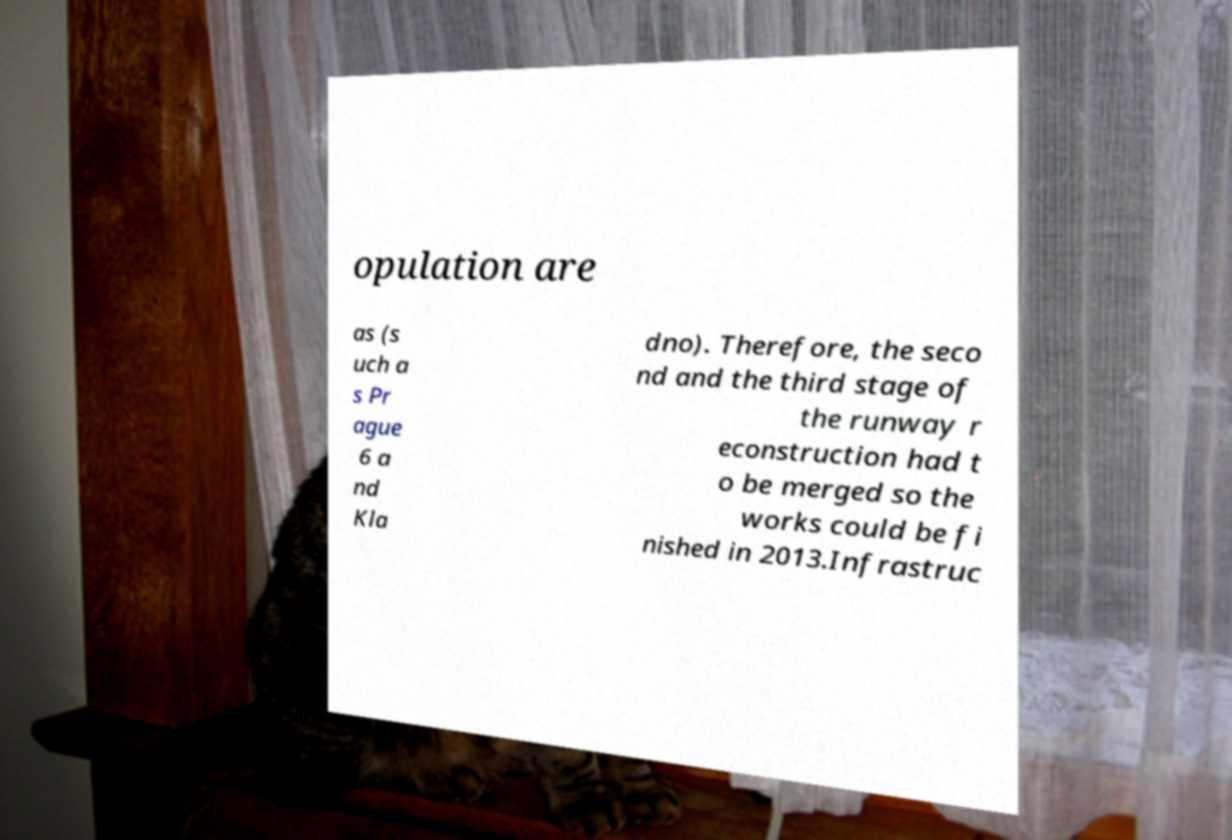Please read and relay the text visible in this image. What does it say? opulation are as (s uch a s Pr ague 6 a nd Kla dno). Therefore, the seco nd and the third stage of the runway r econstruction had t o be merged so the works could be fi nished in 2013.Infrastruc 